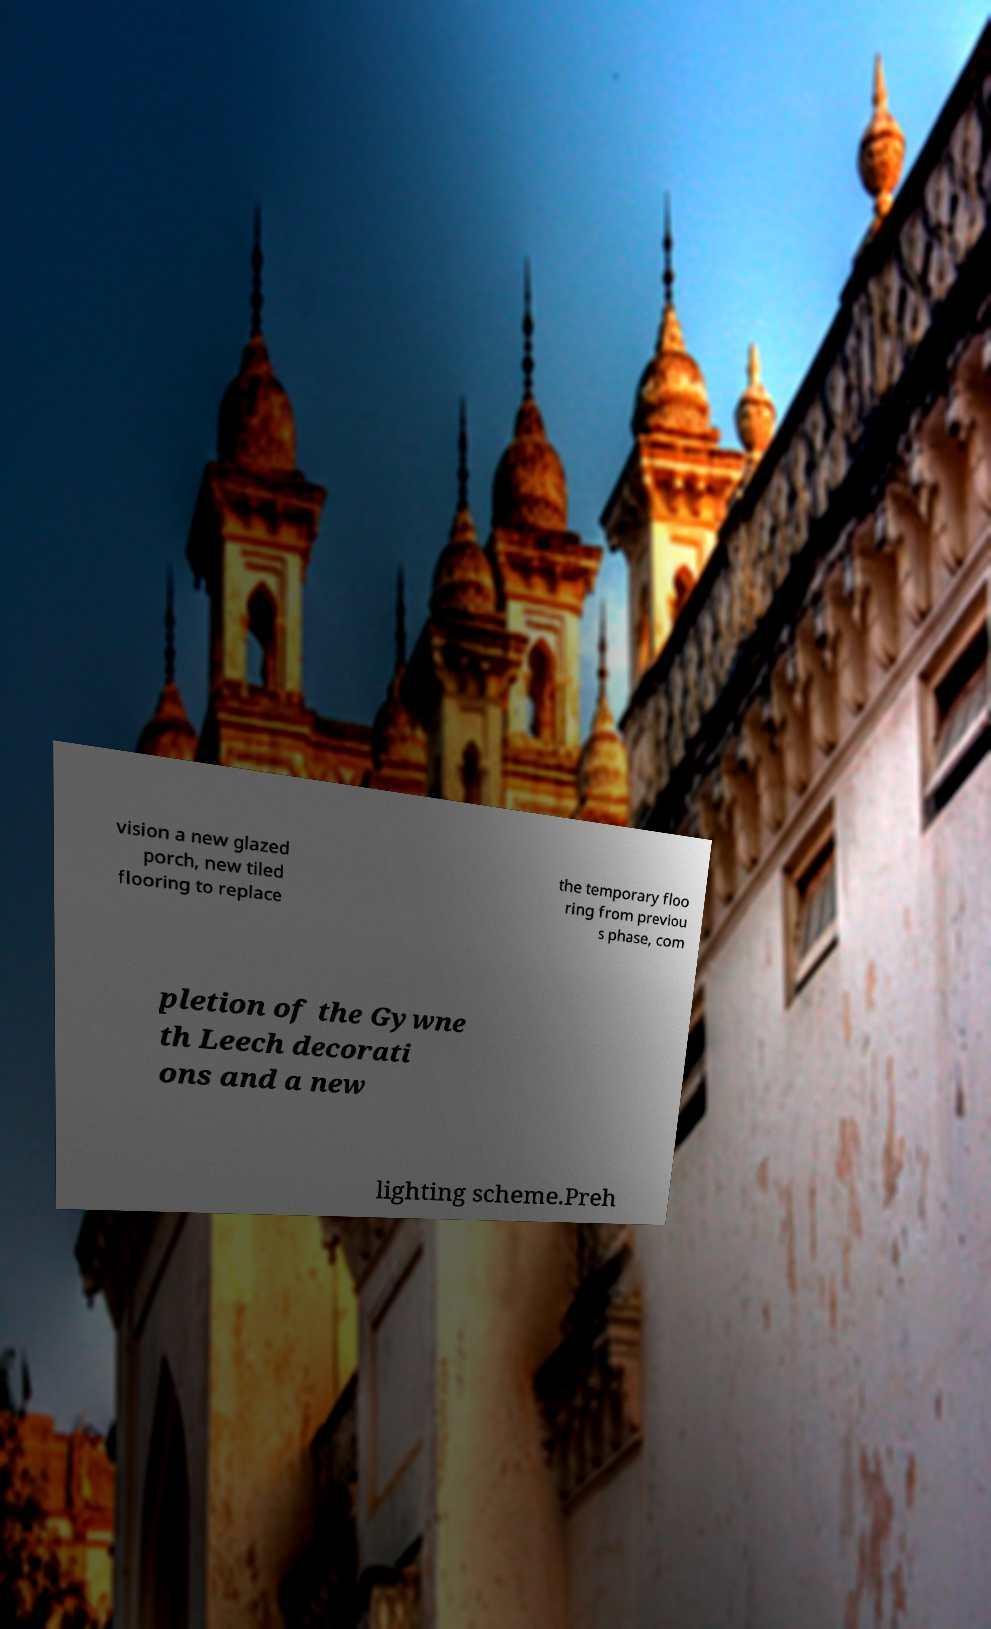Can you read and provide the text displayed in the image?This photo seems to have some interesting text. Can you extract and type it out for me? vision a new glazed porch, new tiled flooring to replace the temporary floo ring from previou s phase, com pletion of the Gywne th Leech decorati ons and a new lighting scheme.Preh 